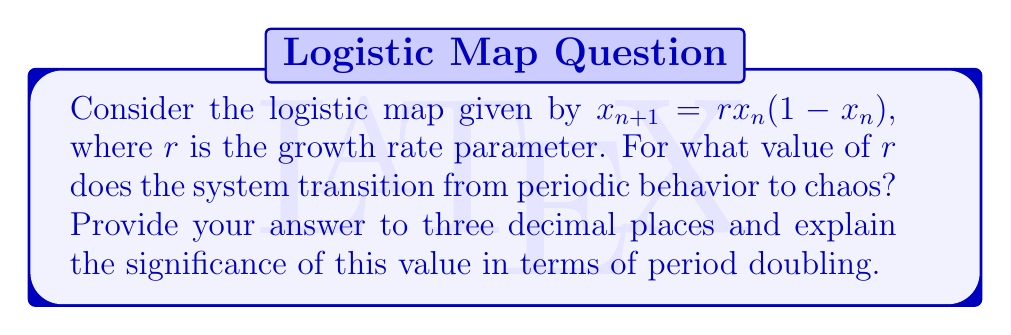Give your solution to this math problem. Let's approach this step-by-step:

1) The logistic map undergoes a series of period-doubling bifurcations as $r$ increases.

2) These bifurcations occur at increasingly shorter intervals, converging to a limit.

3) This limit is known as the Feigenbaum constant, approximately 4.669201...

4) The transition to chaos occurs at the accumulation point of these period-doubling bifurcations.

5) This accumulation point is denoted as $r_∞$ and can be calculated:

   $$r_∞ ≈ 3.569945672...$$

6) At this point, the system transitions from periodic behavior to chaos.

7) The significance of this value:
   - For $r < r_∞$, the system exhibits periodic behavior.
   - For $r > r_∞$, the system shows chaotic behavior, with some "windows" of periodicity.

8) This transition represents the end of the period-doubling cascade and the onset of chaos.

9) In programming terms, this value could be seen as a "breakpoint" where the system's behavior fundamentally changes.
Answer: $r ≈ 3.570$ 